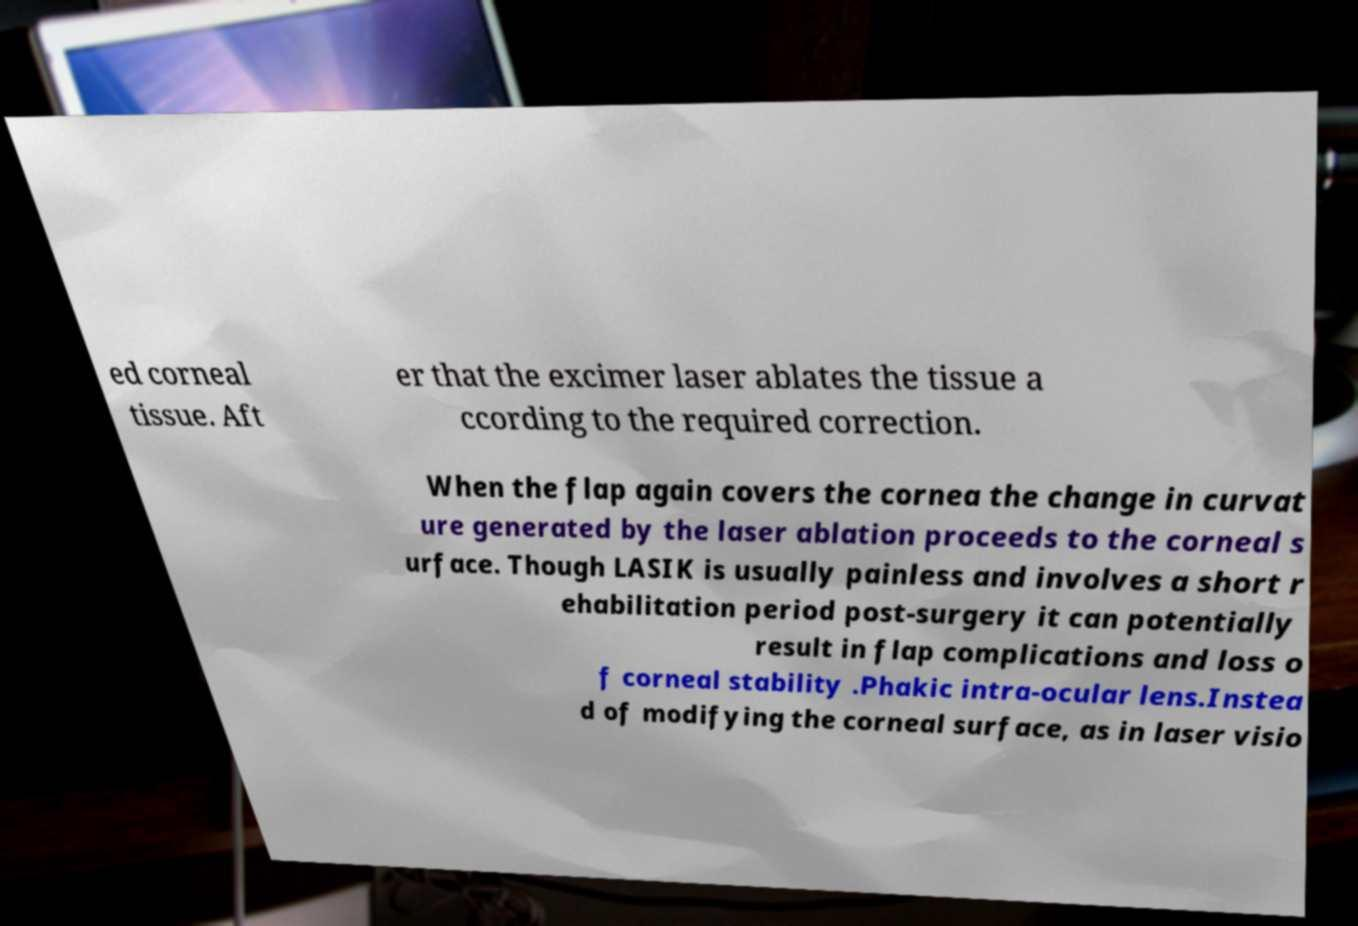For documentation purposes, I need the text within this image transcribed. Could you provide that? ed corneal tissue. Aft er that the excimer laser ablates the tissue a ccording to the required correction. When the flap again covers the cornea the change in curvat ure generated by the laser ablation proceeds to the corneal s urface. Though LASIK is usually painless and involves a short r ehabilitation period post-surgery it can potentially result in flap complications and loss o f corneal stability .Phakic intra-ocular lens.Instea d of modifying the corneal surface, as in laser visio 